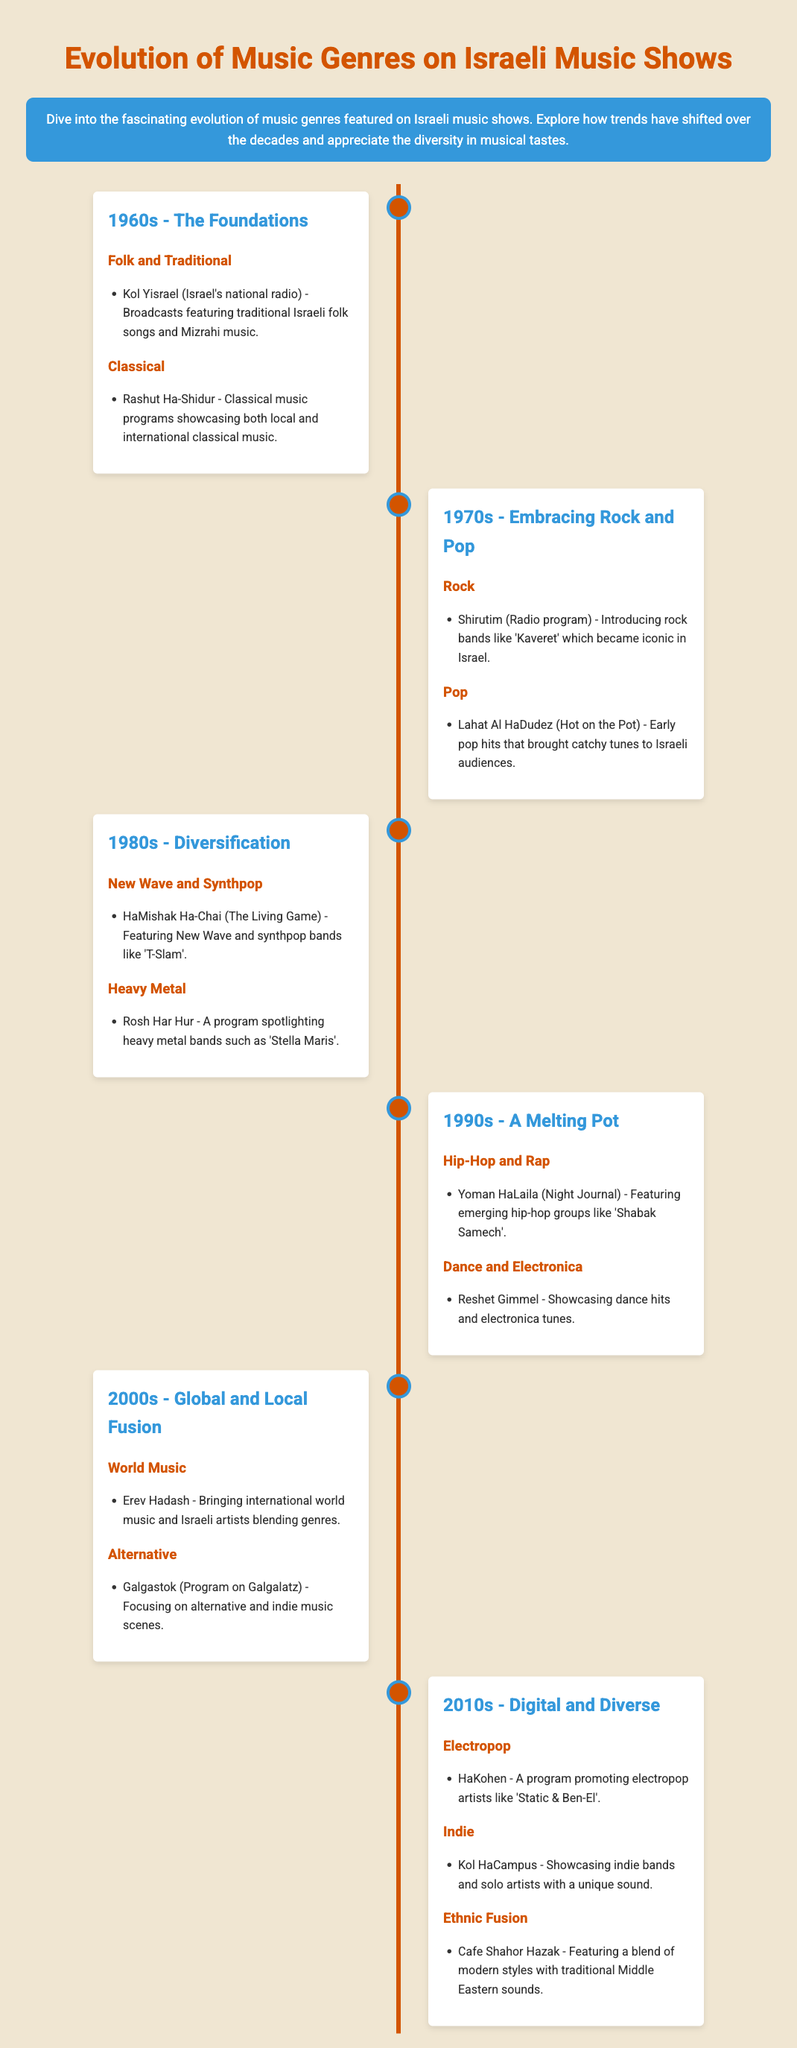what was the dominant music genre in the 1960s? The main genres featured in the 1960s include folk, traditional, and classical music showcased through various programs.
Answer: Folk and Traditional which radio program introduced rock music in the 1970s? The program 'Shirutim' introduced rock bands that were significant in the 1970s.
Answer: Shirutim name one prominent band featured in the 1980s. The program 'HaMishak Ha-Chai' featured the New Wave band 'T-Slam'.
Answer: T-Slam in which decade did hip-hop emerge on Israeli music shows? The emergence of hip-hop was notable in the 1990s, as evidenced by the program 'Yoman HaLaila'.
Answer: 1990s which show highlighted world music in the 2000s? The program 'Erev Hadash' brought international world music and local artists to the audience.
Answer: Erev Hadash what genre gained popularity in the 2010s? The document lists electropop among the popular genres in the 2010s, highlighted in the program 'HaKohen'.
Answer: Electropop how does the 1990s music genre representation compare to the 1980s? The 1990s introduced hip-hop and electronica, adding more diversity compared to the 1980s, which primarily featured rock and heavy metal.
Answer: More diverse what is a unique feature of Cafe Shahor Hazak's program? The program 'Cafe Shahor Hazak' is noted for blending modern styles with traditional Middle Eastern sounds.
Answer: Ethnic Fusion which type of music was featured most consistently throughout the decades? Traditional Israeli folk music has been consistently featured over the decades starting from the 1960s.
Answer: Folk music 